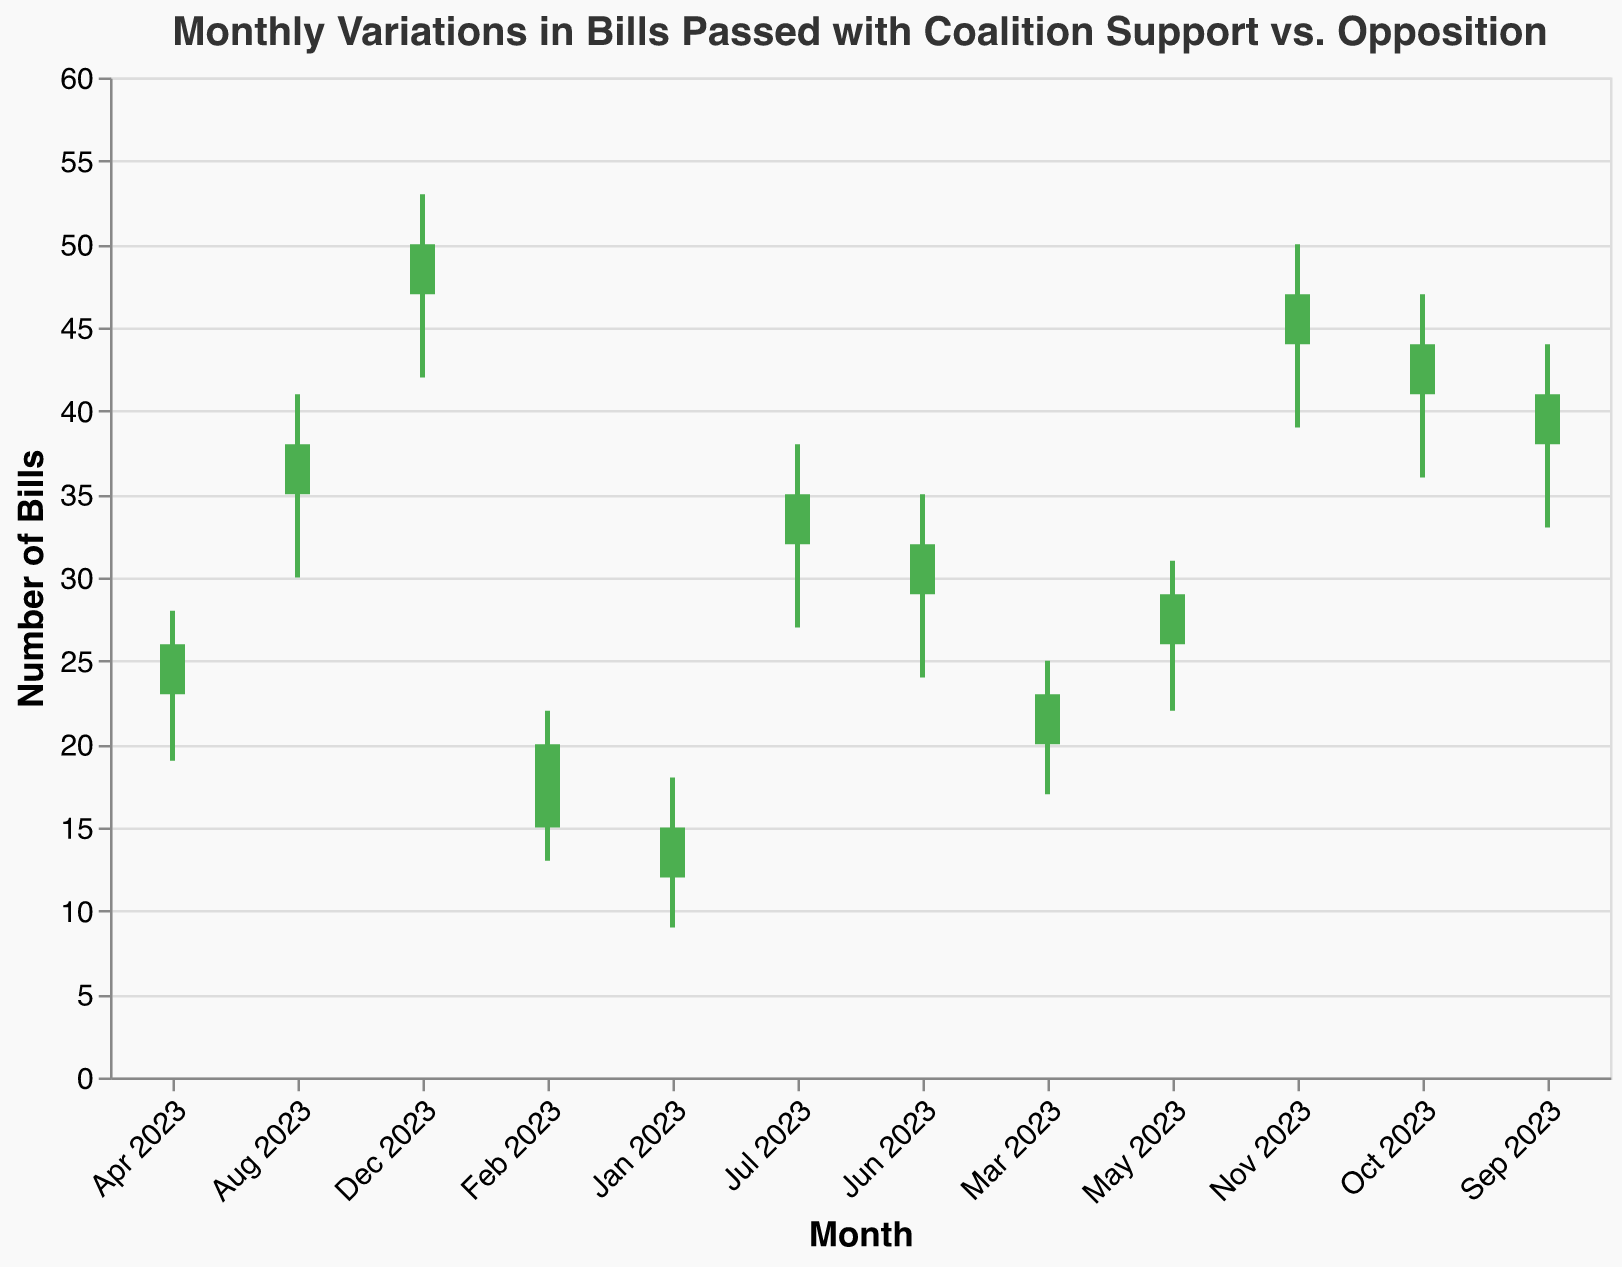What's the title of the figure? The title of the figure is located at the top and is "Monthly Variations in Bills Passed with Coalition Support vs. Opposition."
Answer: Monthly Variations in Bills Passed with Coalition Support vs. Opposition How many data points are there in the figure? The figure shows data for every month from January 2023 to December 2023, so there are 12 data points.
Answer: 12 Which month saw the highest number of bills passed? The highest number of bills passed, represented by the highest "High" value, occurs in December 2023 with a value of 53.
Answer: December 2023 In which months did the close value exceed the open value? To determine if the close value exceeds the open value, we look for bars colored green. These months are January, February, March, April, May, June, July, August, September, October, November, and December of 2023. The close value exceeds the open value in all months.
Answer: All months Which month had the largest difference between the high and low values? The difference between high and low is calculated by subtracting the low value from the high value for each month. The largest difference occurs in December 2023, where 53 (high) - 42 (low) equals 11.
Answer: December 2023 What was the close value in July 2023? The close value is located at the end of the bar for each month. For July 2023, the close value is 35.
Answer: 35 What trend can you observe from January 2023 to December 2023 in the high values? Observing the high values from January to December, they continuously increase each month, indicating an upward trend in the number of bills passed overall.
Answer: Upward trend Which month had the smallest range between the open and close values? The range is found by subtracting the open value from the close value. All the monthly ranges need to be calculated to determine the smallest. Each month has a range of 3, so there's no unique smallest range.
Answer: All months (3) Did any month have high and low values within the same range as the open and close values? No months show the high and low values within the same range as their open and close values which would indicate no fluctuation within that month.
Answer: No 